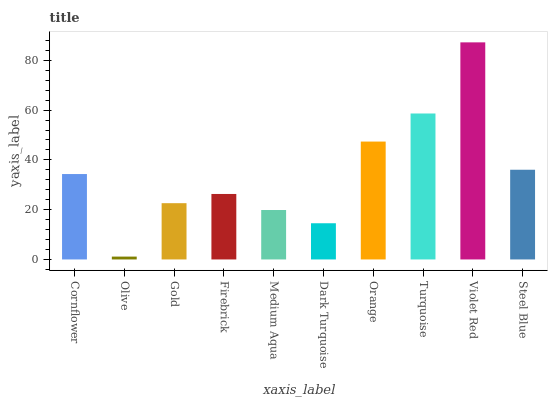Is Olive the minimum?
Answer yes or no. Yes. Is Violet Red the maximum?
Answer yes or no. Yes. Is Gold the minimum?
Answer yes or no. No. Is Gold the maximum?
Answer yes or no. No. Is Gold greater than Olive?
Answer yes or no. Yes. Is Olive less than Gold?
Answer yes or no. Yes. Is Olive greater than Gold?
Answer yes or no. No. Is Gold less than Olive?
Answer yes or no. No. Is Cornflower the high median?
Answer yes or no. Yes. Is Firebrick the low median?
Answer yes or no. Yes. Is Orange the high median?
Answer yes or no. No. Is Orange the low median?
Answer yes or no. No. 